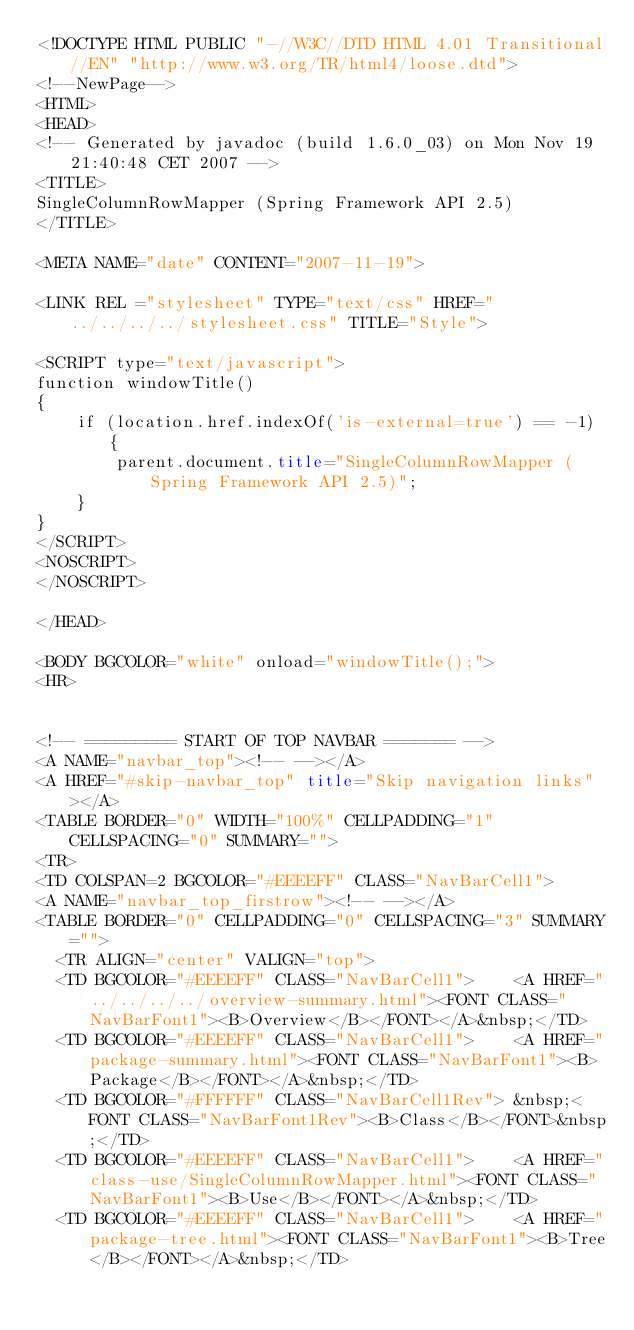<code> <loc_0><loc_0><loc_500><loc_500><_HTML_><!DOCTYPE HTML PUBLIC "-//W3C//DTD HTML 4.01 Transitional//EN" "http://www.w3.org/TR/html4/loose.dtd">
<!--NewPage-->
<HTML>
<HEAD>
<!-- Generated by javadoc (build 1.6.0_03) on Mon Nov 19 21:40:48 CET 2007 -->
<TITLE>
SingleColumnRowMapper (Spring Framework API 2.5)
</TITLE>

<META NAME="date" CONTENT="2007-11-19">

<LINK REL ="stylesheet" TYPE="text/css" HREF="../../../../stylesheet.css" TITLE="Style">

<SCRIPT type="text/javascript">
function windowTitle()
{
    if (location.href.indexOf('is-external=true') == -1) {
        parent.document.title="SingleColumnRowMapper (Spring Framework API 2.5)";
    }
}
</SCRIPT>
<NOSCRIPT>
</NOSCRIPT>

</HEAD>

<BODY BGCOLOR="white" onload="windowTitle();">
<HR>


<!-- ========= START OF TOP NAVBAR ======= -->
<A NAME="navbar_top"><!-- --></A>
<A HREF="#skip-navbar_top" title="Skip navigation links"></A>
<TABLE BORDER="0" WIDTH="100%" CELLPADDING="1" CELLSPACING="0" SUMMARY="">
<TR>
<TD COLSPAN=2 BGCOLOR="#EEEEFF" CLASS="NavBarCell1">
<A NAME="navbar_top_firstrow"><!-- --></A>
<TABLE BORDER="0" CELLPADDING="0" CELLSPACING="3" SUMMARY="">
  <TR ALIGN="center" VALIGN="top">
  <TD BGCOLOR="#EEEEFF" CLASS="NavBarCell1">    <A HREF="../../../../overview-summary.html"><FONT CLASS="NavBarFont1"><B>Overview</B></FONT></A>&nbsp;</TD>
  <TD BGCOLOR="#EEEEFF" CLASS="NavBarCell1">    <A HREF="package-summary.html"><FONT CLASS="NavBarFont1"><B>Package</B></FONT></A>&nbsp;</TD>
  <TD BGCOLOR="#FFFFFF" CLASS="NavBarCell1Rev"> &nbsp;<FONT CLASS="NavBarFont1Rev"><B>Class</B></FONT>&nbsp;</TD>
  <TD BGCOLOR="#EEEEFF" CLASS="NavBarCell1">    <A HREF="class-use/SingleColumnRowMapper.html"><FONT CLASS="NavBarFont1"><B>Use</B></FONT></A>&nbsp;</TD>
  <TD BGCOLOR="#EEEEFF" CLASS="NavBarCell1">    <A HREF="package-tree.html"><FONT CLASS="NavBarFont1"><B>Tree</B></FONT></A>&nbsp;</TD></code> 